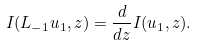Convert formula to latex. <formula><loc_0><loc_0><loc_500><loc_500>I ( L _ { - 1 } u _ { 1 } , z ) = \frac { d } { d z } I ( u _ { 1 } , z ) .</formula> 